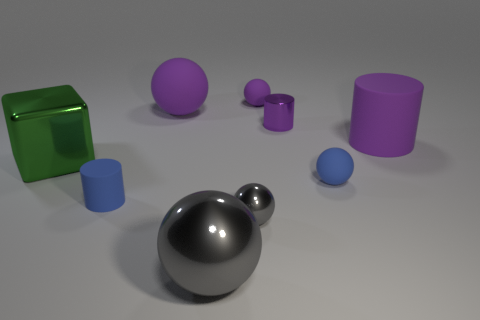There is a metallic thing that is the same color as the large metallic ball; what size is it?
Keep it short and to the point. Small. How many objects are tiny cylinders in front of the green cube or large spheres?
Ensure brevity in your answer.  3. There is a big rubber object that is the same color as the big cylinder; what shape is it?
Provide a short and direct response. Sphere. What is the blue object that is on the right side of the tiny cylinder behind the large cube made of?
Your response must be concise. Rubber. Is there a large ball that has the same material as the blue cylinder?
Offer a very short reply. Yes. Is there a large cylinder to the left of the small cylinder that is to the right of the small gray sphere?
Offer a very short reply. No. What is the large purple ball behind the blue cylinder made of?
Offer a terse response. Rubber. Does the green shiny thing have the same shape as the small purple shiny thing?
Keep it short and to the point. No. There is a large thing that is in front of the big metal thing that is on the left side of the small cylinder that is left of the big gray shiny object; what color is it?
Offer a very short reply. Gray. What number of green metallic things have the same shape as the large gray object?
Your response must be concise. 0. 